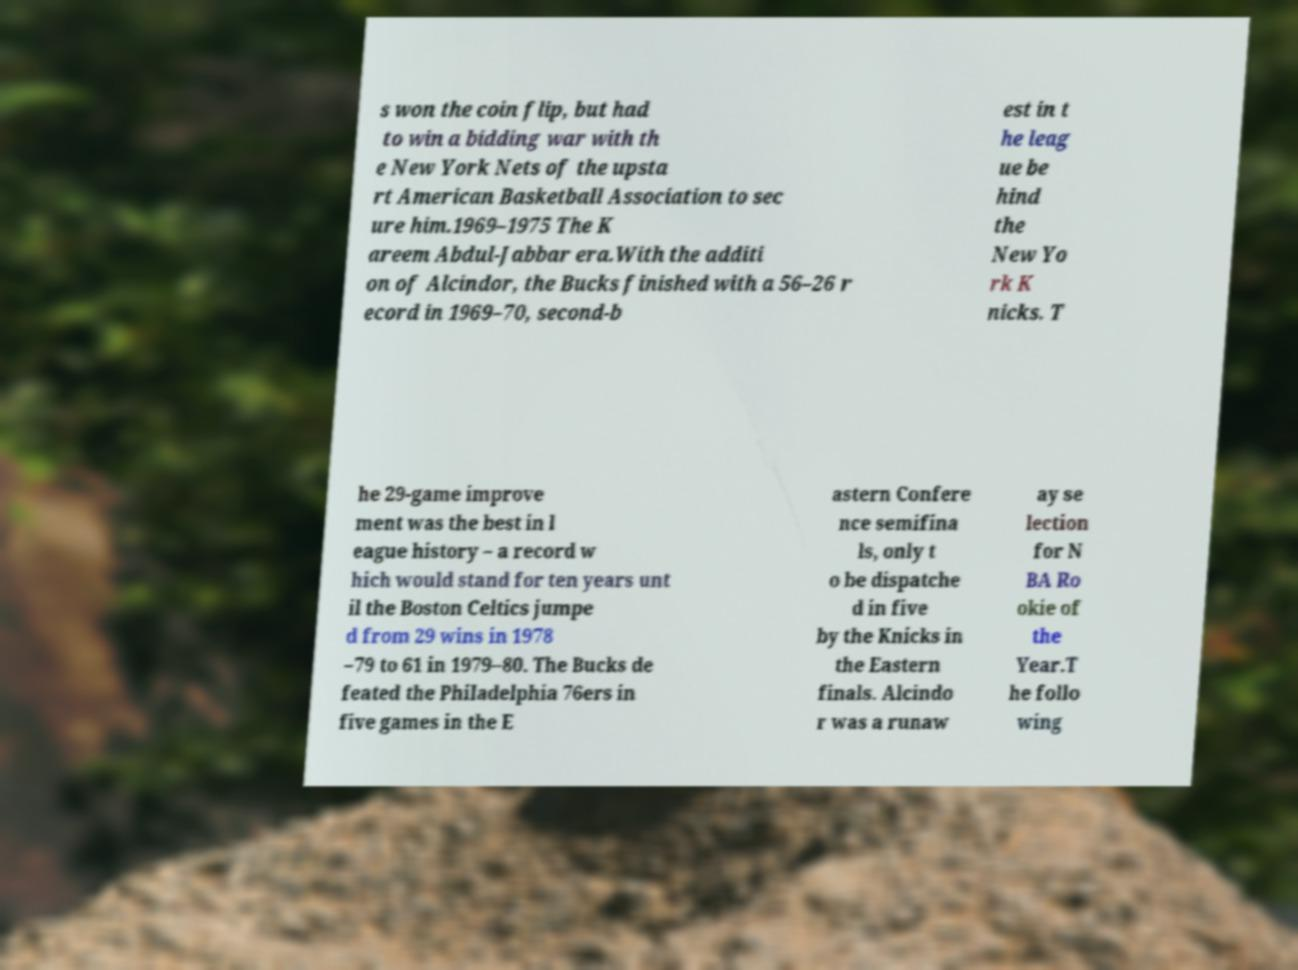Please identify and transcribe the text found in this image. s won the coin flip, but had to win a bidding war with th e New York Nets of the upsta rt American Basketball Association to sec ure him.1969–1975 The K areem Abdul-Jabbar era.With the additi on of Alcindor, the Bucks finished with a 56–26 r ecord in 1969–70, second-b est in t he leag ue be hind the New Yo rk K nicks. T he 29-game improve ment was the best in l eague history – a record w hich would stand for ten years unt il the Boston Celtics jumpe d from 29 wins in 1978 –79 to 61 in 1979–80. The Bucks de feated the Philadelphia 76ers in five games in the E astern Confere nce semifina ls, only t o be dispatche d in five by the Knicks in the Eastern finals. Alcindo r was a runaw ay se lection for N BA Ro okie of the Year.T he follo wing 